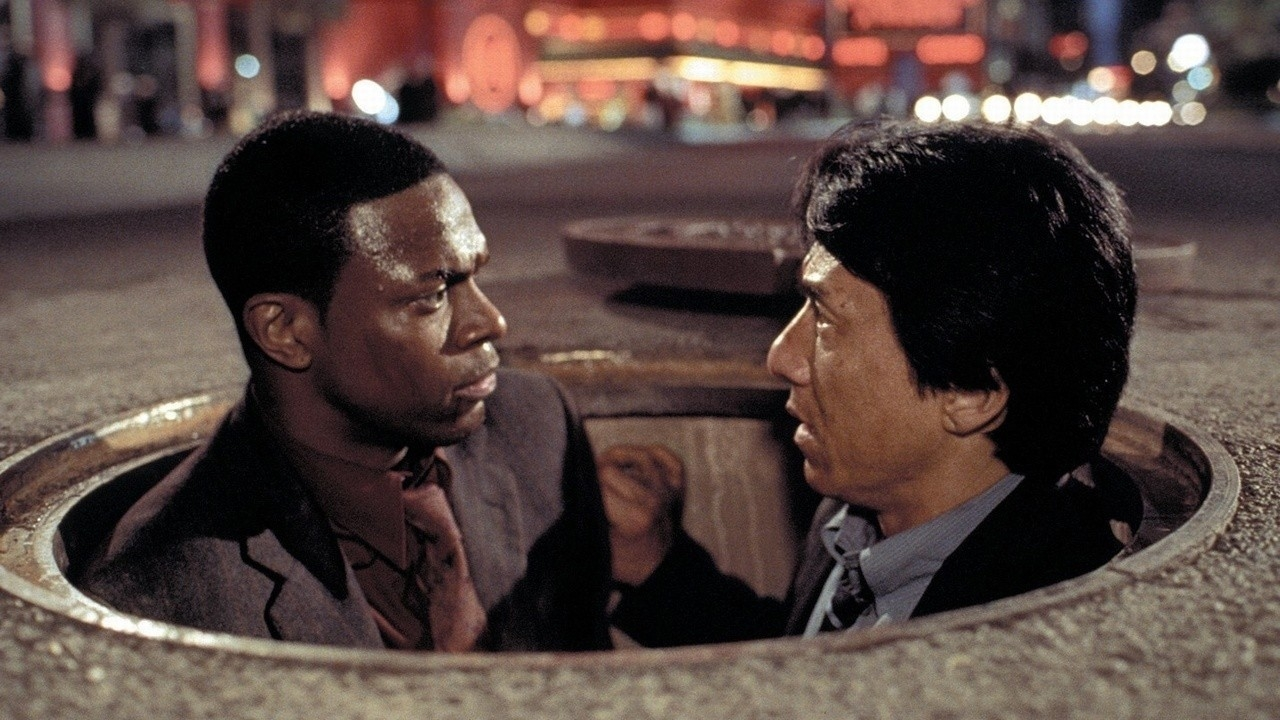If this scene was a painting, how would it be titled and why? If this scene was a painting, it could be titled 'Underground Standoff'. The title captures the essence of the scene, focusing on the serious, confrontational glares exchanged by the two characters amidst the backdrop of a manhole. This title emphasizes the tension and significance of the moment, as well as the unconventional setting that adds a layer of intrigue and suspense. 